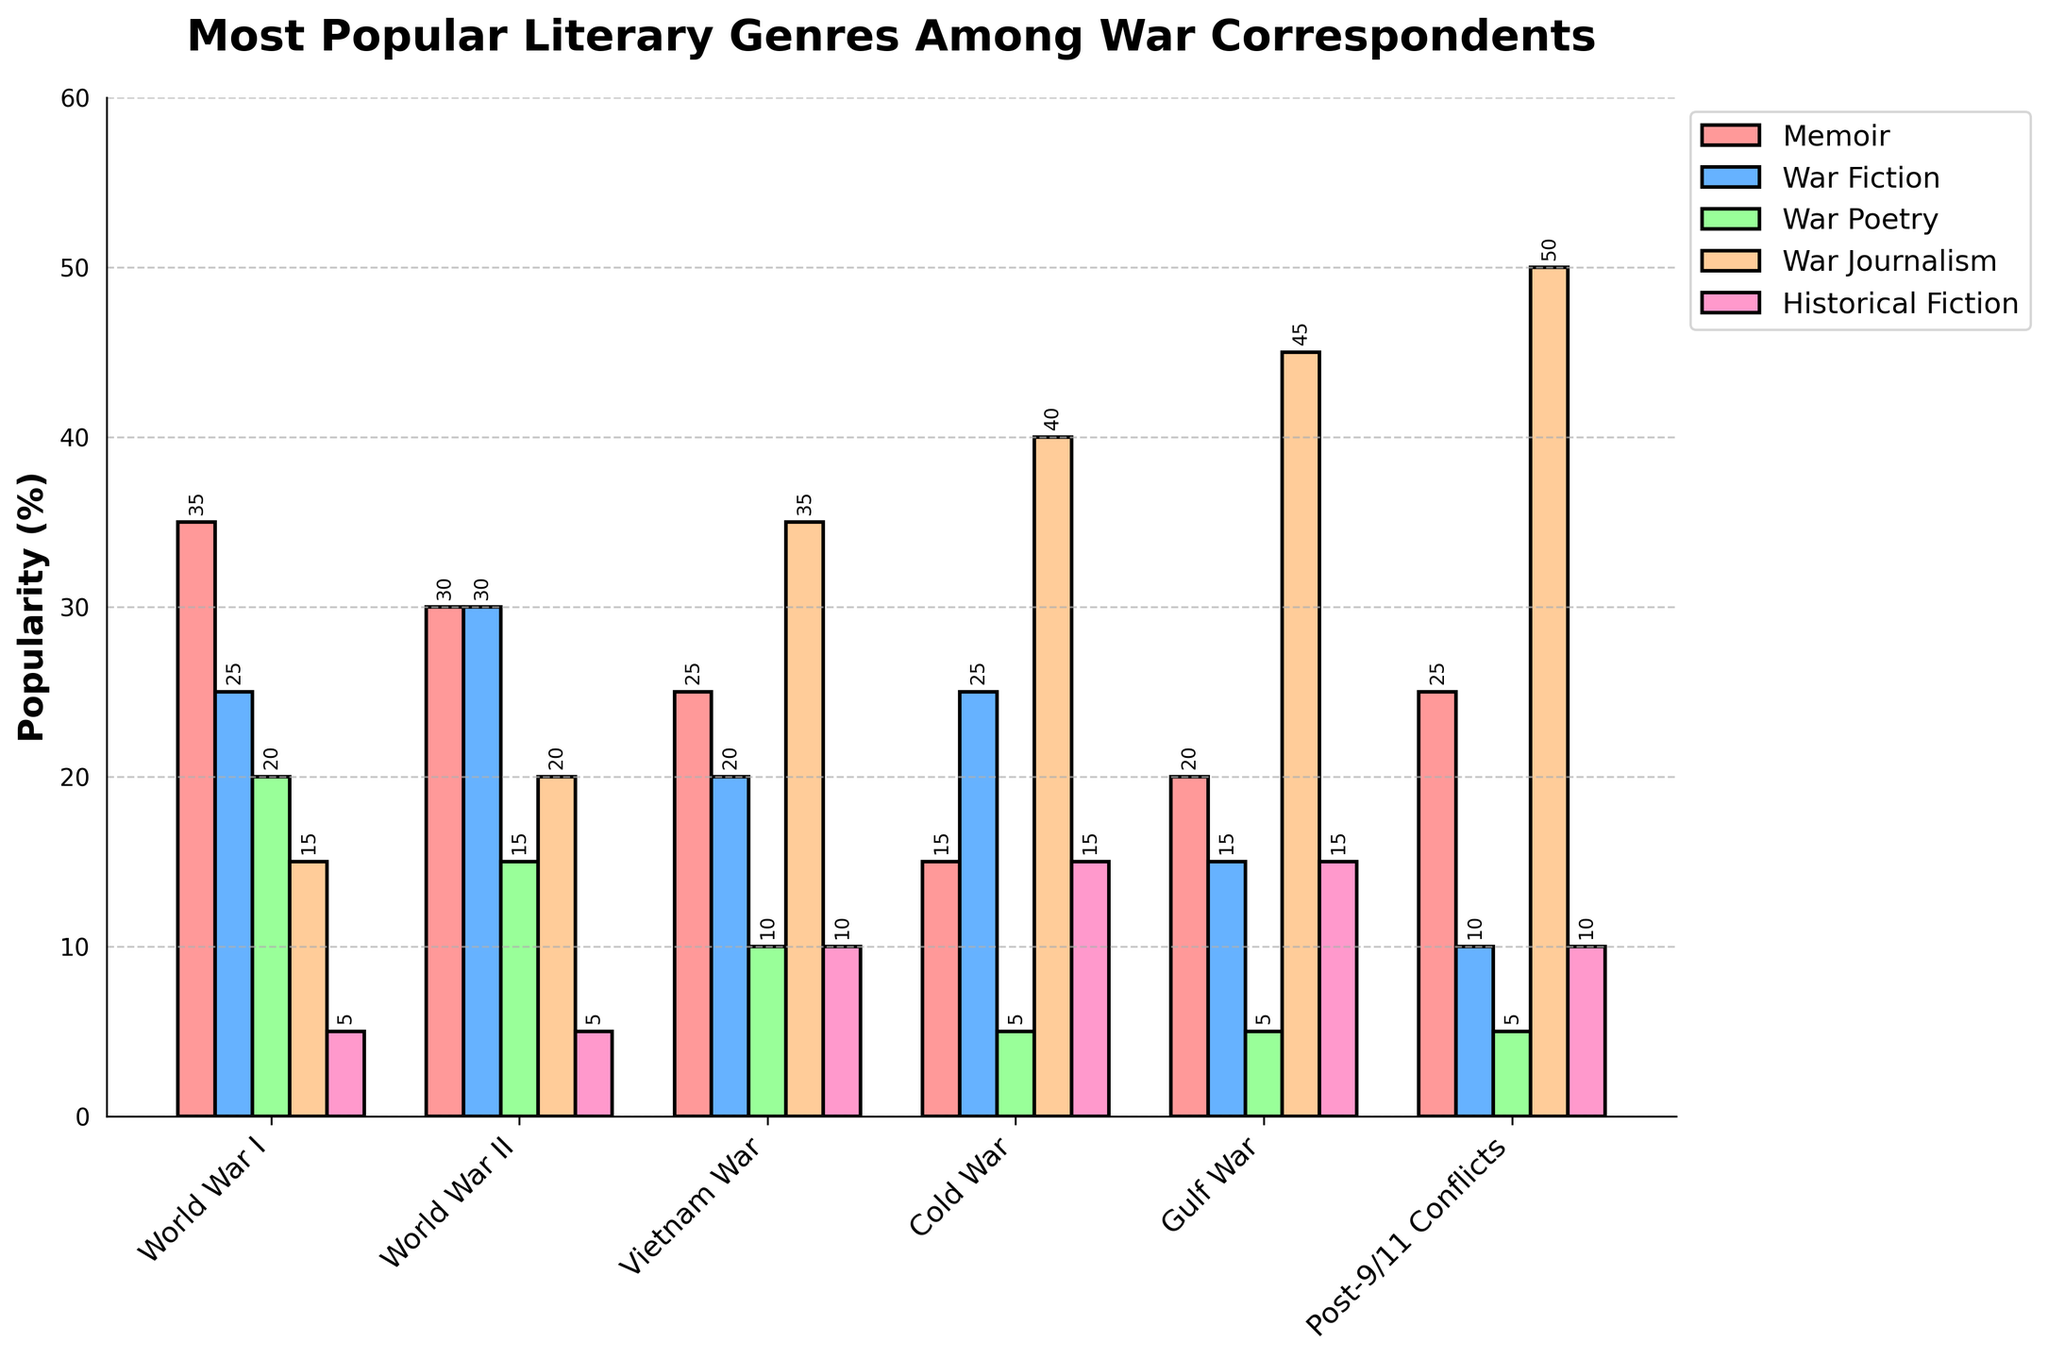Which historical period had the highest popularity for War Journalism? Look at the bar representing War Journalism across all historical periods and identify which one has the tallest bar. War Journalism is most popular during the Post-9/11 Conflicts period with a percentage of 50.
Answer: Post-9/11 Conflicts How does the popularity of Memoir compare between World War I and World War II? Compare the height of the Memoir bars for World War I and World War II. The Memoir bar is taller for World War I (35) than for World War II (30).
Answer: World War I What is the total popularity percentage of War Fiction during the Cold War and Gulf War combined? Add the percentages for Cold War and Gulf War from the War Fiction bars: 25 (Cold War) + 15 (Gulf War) = 40.
Answer: 40 Which genre saw the least popularity during the Vietnam War? Identify the shortest bar for the Vietnam War category. The War Poetry bar is the shortest with a value of 10.
Answer: War Poetry Which historical period had the lowest popularity for Historical Fiction? Compare the heights of all Historical Fiction bars across periods and identify the shortest, which is during World War I with a value of 5.
Answer: World War I What is the difference in popularity for Memoir between the Vietnam War and Post-9/11 Conflicts? Subtract the Memoir percentage of the Vietnam War (25) from that of Post-9/11 Conflicts (25): 25 - 25 = 0.
Answer: 0 How does the popularity of War Poetry change from World War I to World War II? Compare the War Poetry bars for both periods. War Poetry popularity decreases from 20 in World War I to 15 in World War II.
Answer: decreases What is the combined popularity percentage of Historical Fiction and War Fiction during World War I? Add the percentages for Historical Fiction and War Fiction for World War I: 5 (Historical Fiction) + 25 (War Fiction) = 30.
Answer: 30 Which historical period shows the highest popularity for War Fiction? Observe the height of War Fiction bars across all periods and identify the tallest one, which belongs to World War II with a value of 30.
Answer: World War II What is the visual difference between the War Journalism bar during the Cold War and World War II? Compare the heights of the War Journalism bars for Cold War (40) and World War II (20). The War Journalism bar is twice as tall in the Cold War compared to World War II.
Answer: Cold War bar is taller 